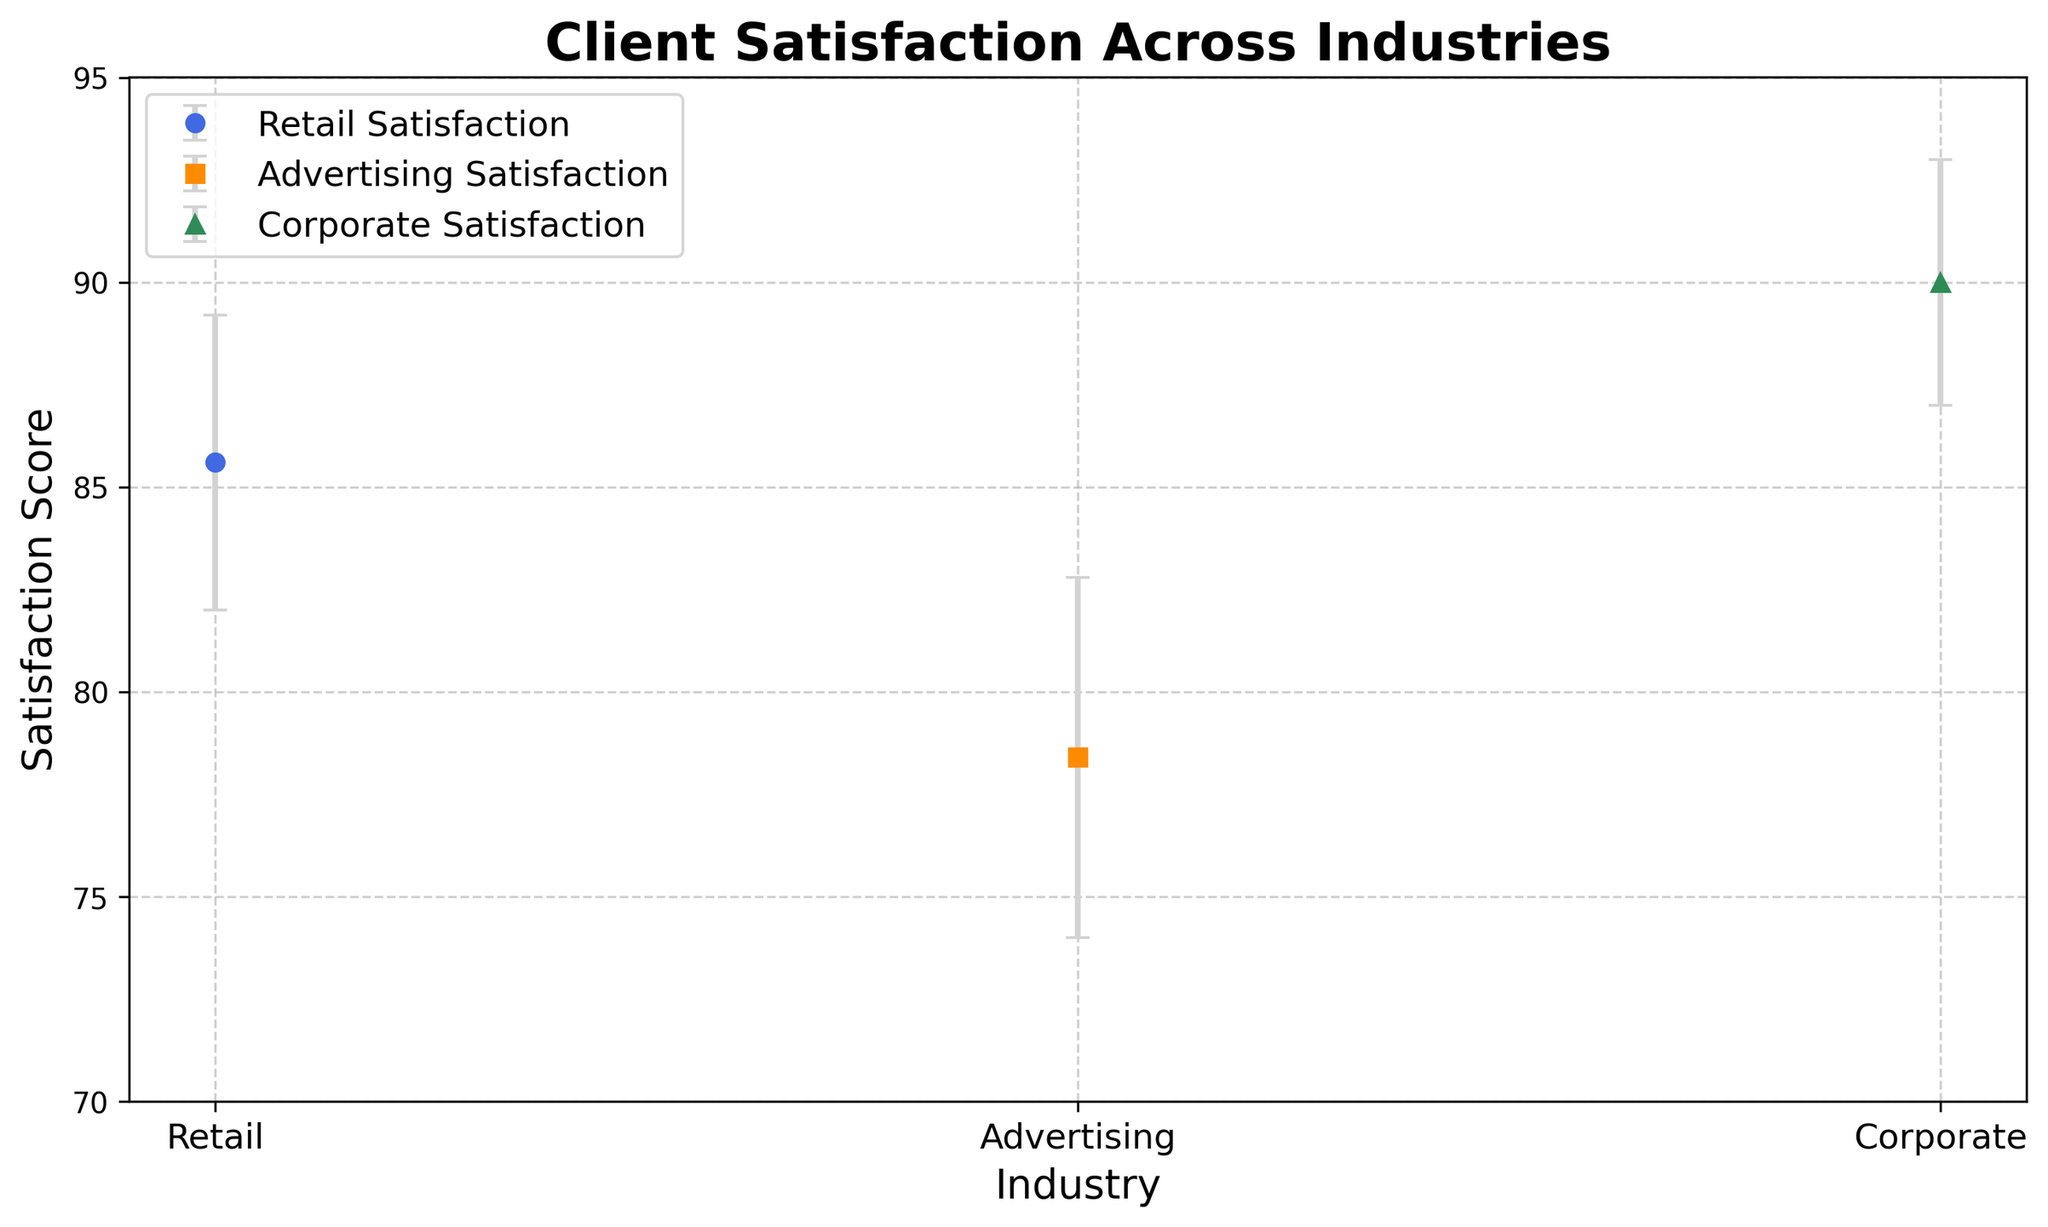What is the average Client Satisfaction Score for the retail industry? The retail industry's Client Satisfaction Scores are 85, 88, 82, 90, and 83. Summing these values gives 428. Dividing by the number of data points (5) gives the average: 428/5 = 85.6.
Answer: 85.6 Which industry has the highest average Client Satisfaction Score? Looking at the mean scores indicated by the markers on the plot, the Corporate industry has the marker placed higher than the others, indicating the highest average Client Satisfaction Score.
Answer: Corporate What is the difference between the average Client Satisfaction Scores of the Corporate and Advertising industries? The Corporate industry's average score is around 90, while the Advertising industry's average score is around 78. The difference is 90 - 78 = 12.
Answer: 12 Which industry shows the largest error bars in Client Satisfaction Scores? The plot shows the length of the error bars for each industry. The Advertising industry has the largest error bars, suggesting the highest variability in response rates.
Answer: Advertising How does the average Client Satisfaction Score for the Retail industry compare to the Corporate industry? The Retail industry's average score is around 85.6, and the Corporate industry's average score is around 90. Therefore, the Corporate industry has a higher average score compared to Retail.
Answer: Corporate higher What is the range (from lowest to highest) of Client Satisfaction Scores within the Retail industry? The Retail industry's scores are 85, 88, 82, 90, and 83. The lowest score is 82, and the highest is 90, thus the range is 90 - 82 = 8.
Answer: 8 Which industry has the lowest average Client Satisfaction Score? By looking at the plot and the markers' positions for each industry, the Advertising industry has the lowest average Client Satisfaction Score.
Answer: Advertising How do the mean Client Satisfaction Scores for Advertising and Retail industries differ? The Advertising industry has an average score around 78, whereas the Retail industry has an average score around 85.6. The difference is 85.6 - 78 = 7.6.
Answer: 7.6 What can you infer from the error bar lengths about the variability in Client Satisfaction within each industry? The lengths of the error bars represent variability in data. Advertising has the longest error bars, suggesting high variability; Corporate has the shortest error bars, indicating low variability, and Retail's error bars are intermediate.
Answer: Advertising: high variability; Corporate: low variability; Retail: intermediate Which industry has the smallest error bars, and what does it imply? The Corporate industry has the smallest error bars, implying greater consistency and lower variability in Client Satisfaction Scores within this industry.
Answer: Corporate 